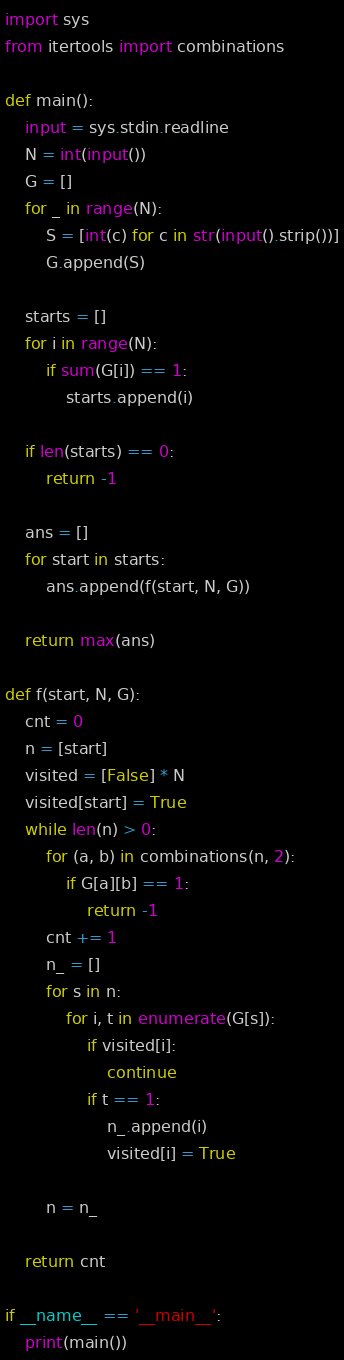<code> <loc_0><loc_0><loc_500><loc_500><_Python_>import sys
from itertools import combinations

def main():
    input = sys.stdin.readline
    N = int(input())
    G = []
    for _ in range(N):
        S = [int(c) for c in str(input().strip())]
        G.append(S)
    
    starts = []
    for i in range(N):
        if sum(G[i]) == 1:
            starts.append(i)
    
    if len(starts) == 0:
        return -1
    
    ans = []
    for start in starts:
        ans.append(f(start, N, G))
    
    return max(ans)
    
def f(start, N, G):
    cnt = 0
    n = [start]
    visited = [False] * N
    visited[start] = True
    while len(n) > 0:
        for (a, b) in combinations(n, 2):
            if G[a][b] == 1:
                return -1
        cnt += 1
        n_ = []
        for s in n:
            for i, t in enumerate(G[s]):
                if visited[i]:
                    continue
                if t == 1:
                    n_.append(i)
                    visited[i] = True
        
        n = n_

    return cnt

if __name__ == '__main__':
    print(main())</code> 